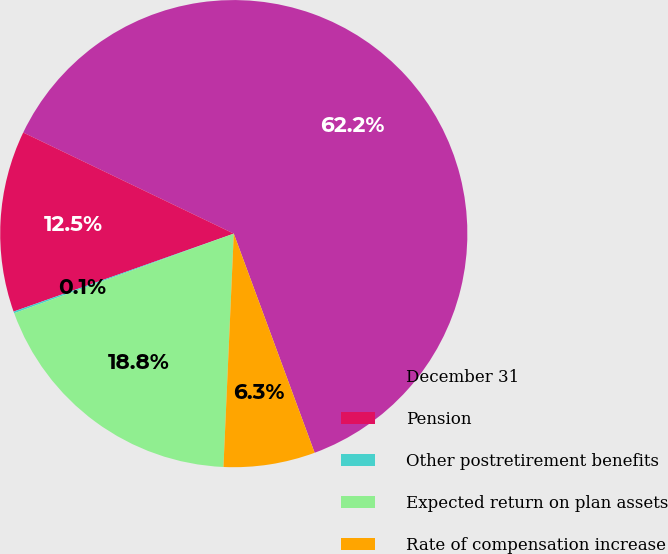Convert chart to OTSL. <chart><loc_0><loc_0><loc_500><loc_500><pie_chart><fcel>December 31<fcel>Pension<fcel>Other postretirement benefits<fcel>Expected return on plan assets<fcel>Rate of compensation increase<nl><fcel>62.25%<fcel>12.54%<fcel>0.12%<fcel>18.76%<fcel>6.33%<nl></chart> 